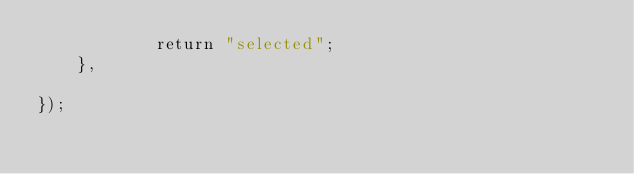<code> <loc_0><loc_0><loc_500><loc_500><_JavaScript_>            return "selected";
    },
    
});</code> 